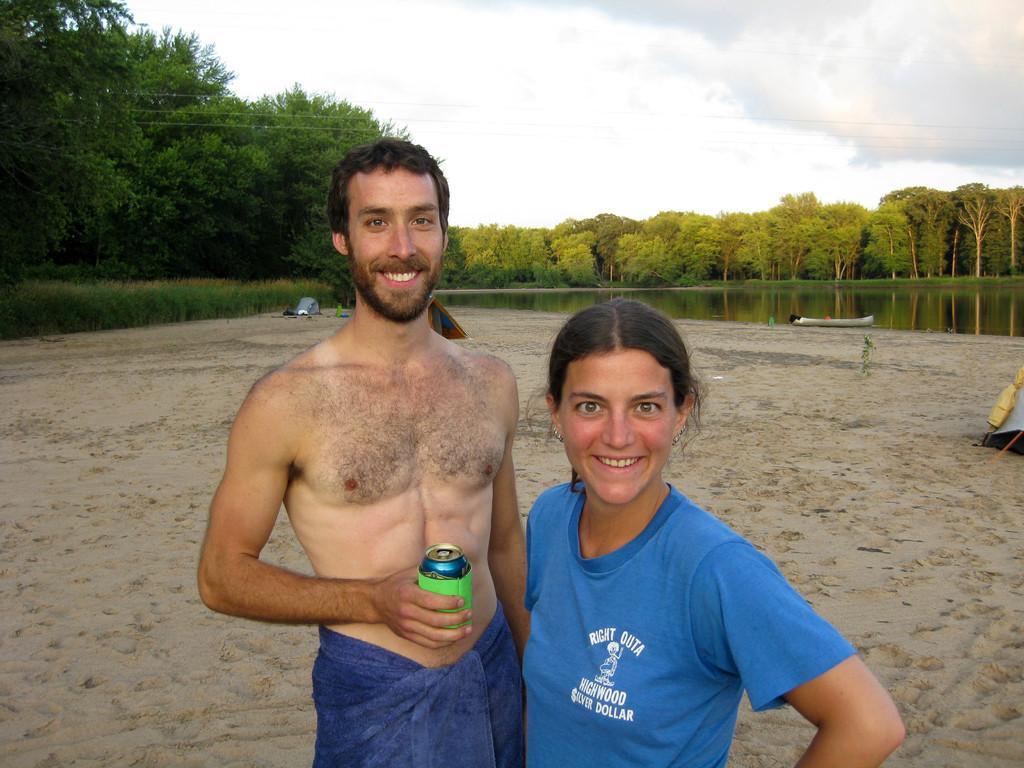Could you give a brief overview of what you see in this image? In this picture we can see a man and woman, they both are smiling, and he is holding a tin, in the background we can see few trees, water, a boat and a tent. 